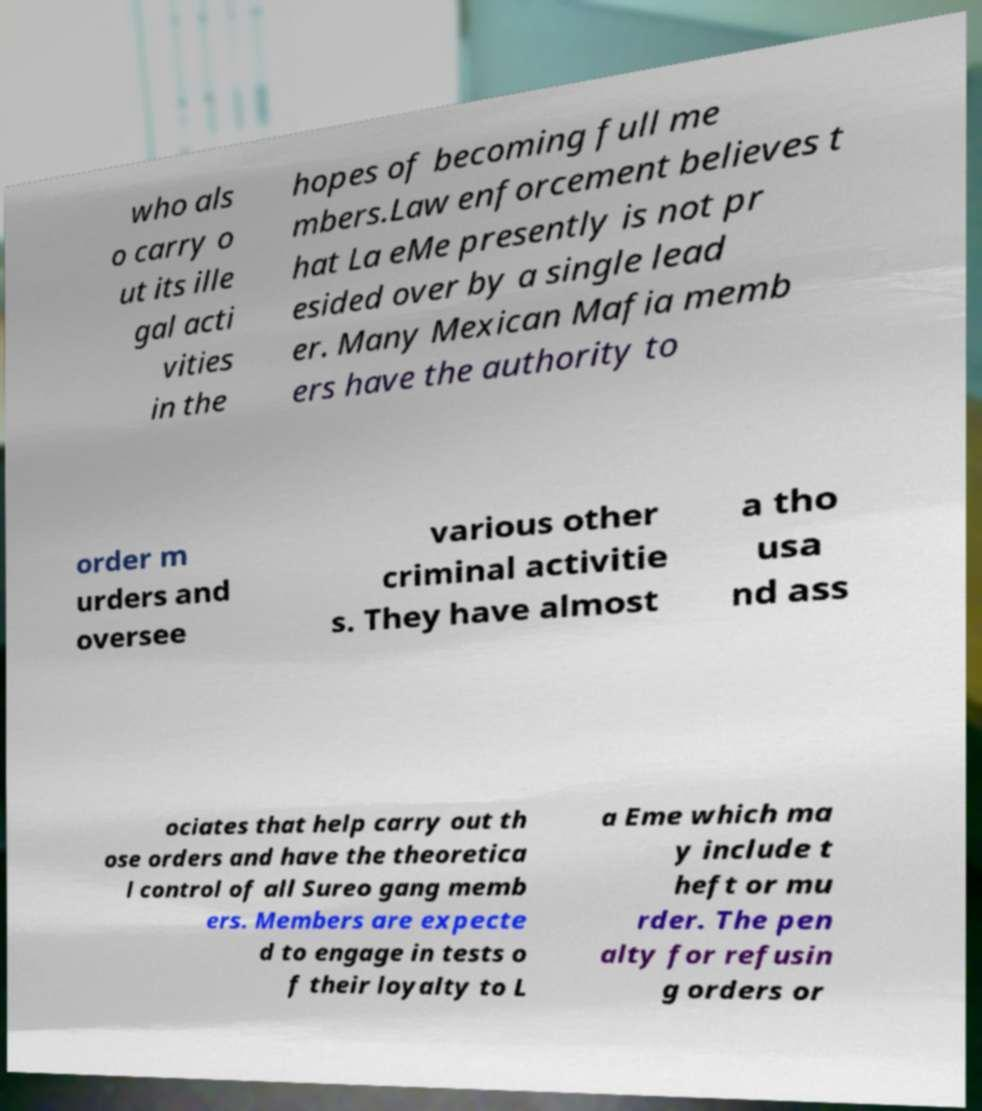Can you accurately transcribe the text from the provided image for me? who als o carry o ut its ille gal acti vities in the hopes of becoming full me mbers.Law enforcement believes t hat La eMe presently is not pr esided over by a single lead er. Many Mexican Mafia memb ers have the authority to order m urders and oversee various other criminal activitie s. They have almost a tho usa nd ass ociates that help carry out th ose orders and have the theoretica l control of all Sureo gang memb ers. Members are expecte d to engage in tests o f their loyalty to L a Eme which ma y include t heft or mu rder. The pen alty for refusin g orders or 